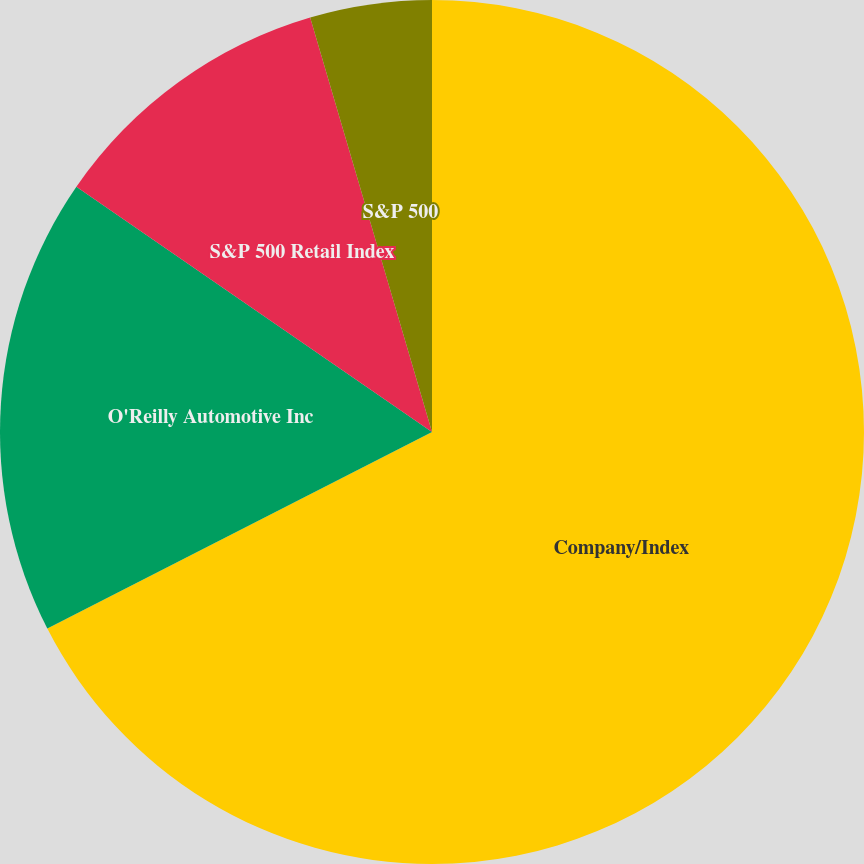<chart> <loc_0><loc_0><loc_500><loc_500><pie_chart><fcel>Company/Index<fcel>O'Reilly Automotive Inc<fcel>S&P 500 Retail Index<fcel>S&P 500<nl><fcel>67.48%<fcel>17.13%<fcel>10.84%<fcel>4.55%<nl></chart> 